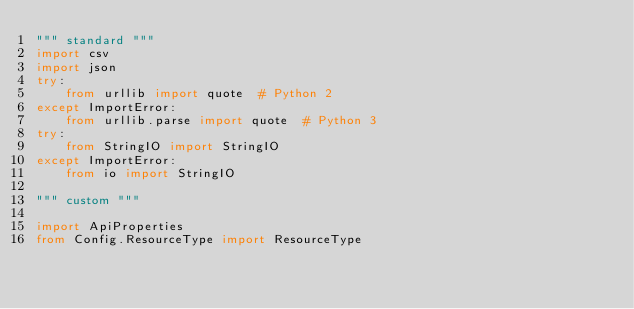Convert code to text. <code><loc_0><loc_0><loc_500><loc_500><_Python_>""" standard """
import csv
import json
try:
    from urllib import quote  # Python 2
except ImportError:
    from urllib.parse import quote  # Python 3
try:
    from StringIO import StringIO
except ImportError:
    from io import StringIO

""" custom """

import ApiProperties
from Config.ResourceType import ResourceType</code> 